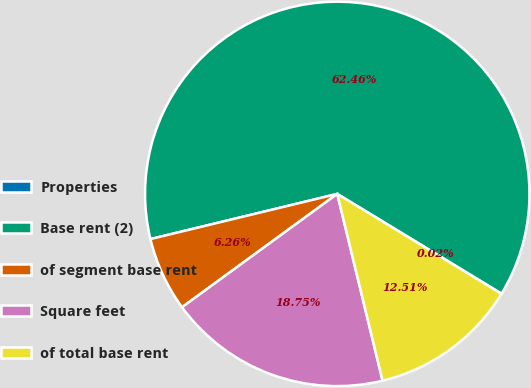<chart> <loc_0><loc_0><loc_500><loc_500><pie_chart><fcel>Properties<fcel>Base rent (2)<fcel>of segment base rent<fcel>Square feet<fcel>of total base rent<nl><fcel>0.02%<fcel>62.46%<fcel>6.26%<fcel>18.75%<fcel>12.51%<nl></chart> 